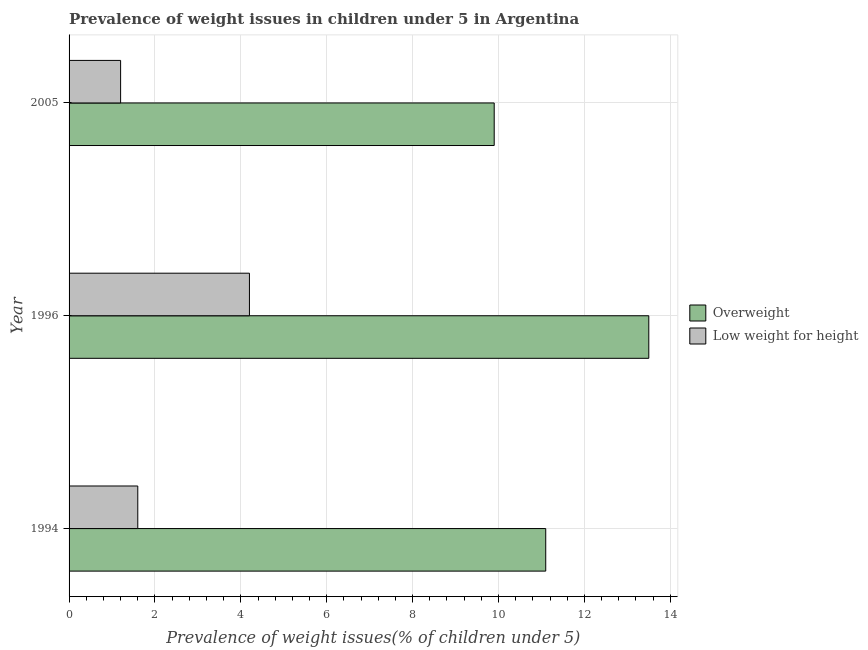How many different coloured bars are there?
Give a very brief answer. 2. Are the number of bars on each tick of the Y-axis equal?
Provide a short and direct response. Yes. How many bars are there on the 3rd tick from the top?
Provide a short and direct response. 2. What is the label of the 1st group of bars from the top?
Offer a very short reply. 2005. In how many cases, is the number of bars for a given year not equal to the number of legend labels?
Your answer should be very brief. 0. What is the percentage of overweight children in 2005?
Offer a terse response. 9.9. Across all years, what is the maximum percentage of underweight children?
Offer a very short reply. 4.2. Across all years, what is the minimum percentage of overweight children?
Provide a succinct answer. 9.9. In which year was the percentage of underweight children maximum?
Provide a succinct answer. 1996. What is the total percentage of underweight children in the graph?
Your response must be concise. 7. What is the difference between the percentage of underweight children in 1994 and that in 1996?
Your answer should be very brief. -2.6. What is the difference between the percentage of underweight children in 1994 and the percentage of overweight children in 2005?
Offer a terse response. -8.3. In how many years, is the percentage of overweight children greater than 1.2000000000000002 %?
Make the answer very short. 3. What is the ratio of the percentage of overweight children in 1994 to that in 2005?
Ensure brevity in your answer.  1.12. Is the percentage of underweight children in 1994 less than that in 1996?
Ensure brevity in your answer.  Yes. In how many years, is the percentage of overweight children greater than the average percentage of overweight children taken over all years?
Make the answer very short. 1. What does the 1st bar from the top in 2005 represents?
Offer a terse response. Low weight for height. What does the 1st bar from the bottom in 1996 represents?
Keep it short and to the point. Overweight. How many bars are there?
Provide a succinct answer. 6. Are all the bars in the graph horizontal?
Make the answer very short. Yes. Are the values on the major ticks of X-axis written in scientific E-notation?
Provide a succinct answer. No. Where does the legend appear in the graph?
Your answer should be very brief. Center right. How many legend labels are there?
Make the answer very short. 2. What is the title of the graph?
Ensure brevity in your answer.  Prevalence of weight issues in children under 5 in Argentina. Does "Stunting" appear as one of the legend labels in the graph?
Provide a succinct answer. No. What is the label or title of the X-axis?
Your answer should be very brief. Prevalence of weight issues(% of children under 5). What is the Prevalence of weight issues(% of children under 5) of Overweight in 1994?
Give a very brief answer. 11.1. What is the Prevalence of weight issues(% of children under 5) in Low weight for height in 1994?
Provide a short and direct response. 1.6. What is the Prevalence of weight issues(% of children under 5) in Overweight in 1996?
Provide a short and direct response. 13.5. What is the Prevalence of weight issues(% of children under 5) in Low weight for height in 1996?
Keep it short and to the point. 4.2. What is the Prevalence of weight issues(% of children under 5) in Overweight in 2005?
Give a very brief answer. 9.9. What is the Prevalence of weight issues(% of children under 5) in Low weight for height in 2005?
Ensure brevity in your answer.  1.2. Across all years, what is the maximum Prevalence of weight issues(% of children under 5) in Low weight for height?
Offer a very short reply. 4.2. Across all years, what is the minimum Prevalence of weight issues(% of children under 5) in Overweight?
Give a very brief answer. 9.9. Across all years, what is the minimum Prevalence of weight issues(% of children under 5) of Low weight for height?
Make the answer very short. 1.2. What is the total Prevalence of weight issues(% of children under 5) in Overweight in the graph?
Make the answer very short. 34.5. What is the difference between the Prevalence of weight issues(% of children under 5) of Overweight in 1994 and that in 1996?
Give a very brief answer. -2.4. What is the difference between the Prevalence of weight issues(% of children under 5) of Overweight in 1994 and that in 2005?
Give a very brief answer. 1.2. What is the difference between the Prevalence of weight issues(% of children under 5) in Low weight for height in 1994 and that in 2005?
Offer a terse response. 0.4. What is the difference between the Prevalence of weight issues(% of children under 5) of Overweight in 1996 and that in 2005?
Ensure brevity in your answer.  3.6. What is the difference between the Prevalence of weight issues(% of children under 5) in Overweight in 1994 and the Prevalence of weight issues(% of children under 5) in Low weight for height in 1996?
Your answer should be very brief. 6.9. What is the difference between the Prevalence of weight issues(% of children under 5) in Overweight in 1996 and the Prevalence of weight issues(% of children under 5) in Low weight for height in 2005?
Give a very brief answer. 12.3. What is the average Prevalence of weight issues(% of children under 5) in Overweight per year?
Your answer should be very brief. 11.5. What is the average Prevalence of weight issues(% of children under 5) in Low weight for height per year?
Offer a terse response. 2.33. In the year 1996, what is the difference between the Prevalence of weight issues(% of children under 5) of Overweight and Prevalence of weight issues(% of children under 5) of Low weight for height?
Offer a terse response. 9.3. What is the ratio of the Prevalence of weight issues(% of children under 5) of Overweight in 1994 to that in 1996?
Your answer should be compact. 0.82. What is the ratio of the Prevalence of weight issues(% of children under 5) in Low weight for height in 1994 to that in 1996?
Make the answer very short. 0.38. What is the ratio of the Prevalence of weight issues(% of children under 5) of Overweight in 1994 to that in 2005?
Offer a very short reply. 1.12. What is the ratio of the Prevalence of weight issues(% of children under 5) of Overweight in 1996 to that in 2005?
Your response must be concise. 1.36. What is the ratio of the Prevalence of weight issues(% of children under 5) in Low weight for height in 1996 to that in 2005?
Provide a succinct answer. 3.5. What is the difference between the highest and the second highest Prevalence of weight issues(% of children under 5) in Overweight?
Give a very brief answer. 2.4. What is the difference between the highest and the lowest Prevalence of weight issues(% of children under 5) in Overweight?
Provide a succinct answer. 3.6. What is the difference between the highest and the lowest Prevalence of weight issues(% of children under 5) of Low weight for height?
Provide a succinct answer. 3. 